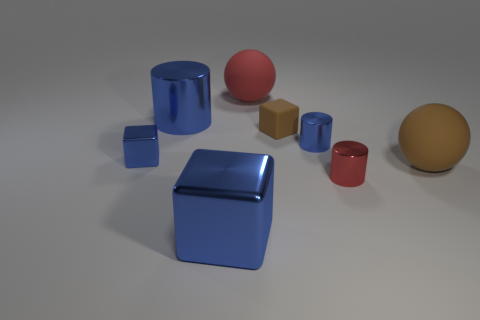Subtract all large blue cylinders. How many cylinders are left? 2 Subtract all red cylinders. How many cylinders are left? 2 Add 2 red cylinders. How many objects exist? 10 Subtract 1 cylinders. How many cylinders are left? 2 Subtract 0 blue spheres. How many objects are left? 8 Subtract all cylinders. How many objects are left? 5 Subtract all gray cylinders. Subtract all green spheres. How many cylinders are left? 3 Subtract all gray cylinders. How many brown cubes are left? 1 Subtract all gray matte balls. Subtract all big red rubber objects. How many objects are left? 7 Add 2 big objects. How many big objects are left? 6 